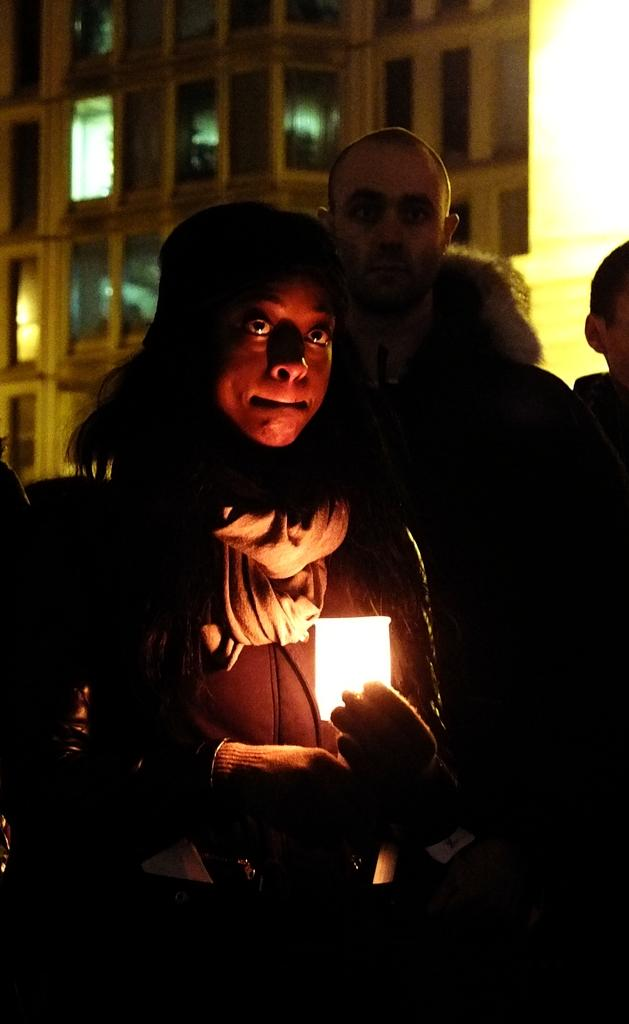How many people are present in the image? There are three persons in the image. What can be seen in the image besides the people? There is a light in the image. What is visible in the background of the image? There is a building in the background of the image. How many cabbages can be seen in the image? There are no cabbages present in the image. What type of train is passing by in the image? There is no train visible in the image. 